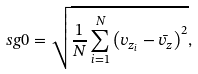Convert formula to latex. <formula><loc_0><loc_0><loc_500><loc_500>\ s g 0 = \sqrt { \frac { 1 } { N } \sum _ { i = 1 } ^ { N } \left ( v _ { z _ { i } } - \bar { v } _ { z } \right ) ^ { 2 } } ,</formula> 